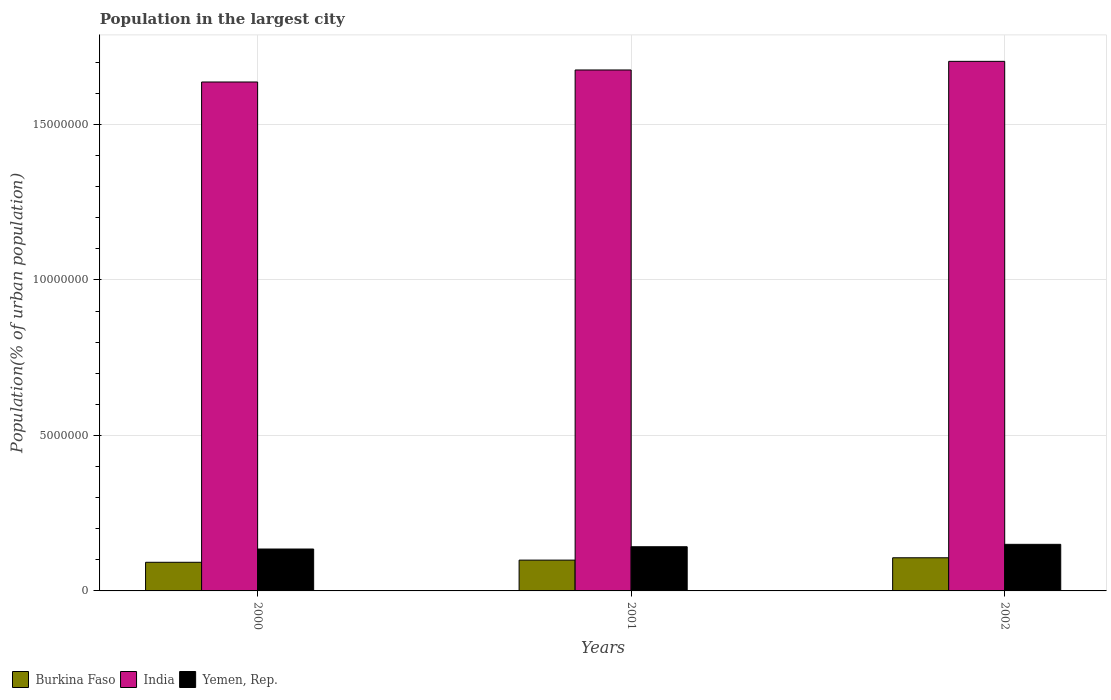How many groups of bars are there?
Provide a succinct answer. 3. Are the number of bars per tick equal to the number of legend labels?
Your response must be concise. Yes. How many bars are there on the 3rd tick from the left?
Your answer should be very brief. 3. What is the label of the 2nd group of bars from the left?
Make the answer very short. 2001. What is the population in the largest city in India in 2002?
Offer a very short reply. 1.70e+07. Across all years, what is the maximum population in the largest city in Burkina Faso?
Provide a short and direct response. 1.07e+06. Across all years, what is the minimum population in the largest city in Yemen, Rep.?
Keep it short and to the point. 1.35e+06. What is the total population in the largest city in Burkina Faso in the graph?
Offer a terse response. 2.98e+06. What is the difference between the population in the largest city in India in 2000 and that in 2002?
Keep it short and to the point. -6.64e+05. What is the difference between the population in the largest city in India in 2001 and the population in the largest city in Yemen, Rep. in 2002?
Provide a short and direct response. 1.53e+07. What is the average population in the largest city in Yemen, Rep. per year?
Give a very brief answer. 1.42e+06. In the year 2000, what is the difference between the population in the largest city in Yemen, Rep. and population in the largest city in India?
Your response must be concise. -1.50e+07. What is the ratio of the population in the largest city in Burkina Faso in 2000 to that in 2001?
Ensure brevity in your answer.  0.93. What is the difference between the highest and the second highest population in the largest city in Yemen, Rep.?
Provide a short and direct response. 7.75e+04. What is the difference between the highest and the lowest population in the largest city in India?
Make the answer very short. 6.64e+05. In how many years, is the population in the largest city in Yemen, Rep. greater than the average population in the largest city in Yemen, Rep. taken over all years?
Your response must be concise. 1. Is the sum of the population in the largest city in India in 2001 and 2002 greater than the maximum population in the largest city in Yemen, Rep. across all years?
Give a very brief answer. Yes. What does the 1st bar from the left in 2000 represents?
Make the answer very short. Burkina Faso. What does the 2nd bar from the right in 2001 represents?
Offer a very short reply. India. Is it the case that in every year, the sum of the population in the largest city in Yemen, Rep. and population in the largest city in Burkina Faso is greater than the population in the largest city in India?
Provide a succinct answer. No. How many years are there in the graph?
Offer a terse response. 3. Are the values on the major ticks of Y-axis written in scientific E-notation?
Give a very brief answer. No. Does the graph contain any zero values?
Ensure brevity in your answer.  No. Where does the legend appear in the graph?
Provide a short and direct response. Bottom left. How are the legend labels stacked?
Your answer should be very brief. Horizontal. What is the title of the graph?
Give a very brief answer. Population in the largest city. What is the label or title of the X-axis?
Give a very brief answer. Years. What is the label or title of the Y-axis?
Ensure brevity in your answer.  Population(% of urban population). What is the Population(% of urban population) in Burkina Faso in 2000?
Keep it short and to the point. 9.21e+05. What is the Population(% of urban population) of India in 2000?
Offer a very short reply. 1.64e+07. What is the Population(% of urban population) of Yemen, Rep. in 2000?
Give a very brief answer. 1.35e+06. What is the Population(% of urban population) in Burkina Faso in 2001?
Make the answer very short. 9.91e+05. What is the Population(% of urban population) of India in 2001?
Your answer should be very brief. 1.68e+07. What is the Population(% of urban population) of Yemen, Rep. in 2001?
Give a very brief answer. 1.42e+06. What is the Population(% of urban population) of Burkina Faso in 2002?
Provide a short and direct response. 1.07e+06. What is the Population(% of urban population) in India in 2002?
Offer a terse response. 1.70e+07. What is the Population(% of urban population) in Yemen, Rep. in 2002?
Provide a succinct answer. 1.50e+06. Across all years, what is the maximum Population(% of urban population) of Burkina Faso?
Your response must be concise. 1.07e+06. Across all years, what is the maximum Population(% of urban population) of India?
Your answer should be very brief. 1.70e+07. Across all years, what is the maximum Population(% of urban population) in Yemen, Rep.?
Give a very brief answer. 1.50e+06. Across all years, what is the minimum Population(% of urban population) in Burkina Faso?
Ensure brevity in your answer.  9.21e+05. Across all years, what is the minimum Population(% of urban population) of India?
Your answer should be very brief. 1.64e+07. Across all years, what is the minimum Population(% of urban population) in Yemen, Rep.?
Make the answer very short. 1.35e+06. What is the total Population(% of urban population) in Burkina Faso in the graph?
Offer a very short reply. 2.98e+06. What is the total Population(% of urban population) of India in the graph?
Offer a terse response. 5.02e+07. What is the total Population(% of urban population) in Yemen, Rep. in the graph?
Your response must be concise. 4.27e+06. What is the difference between the Population(% of urban population) in Burkina Faso in 2000 and that in 2001?
Keep it short and to the point. -6.98e+04. What is the difference between the Population(% of urban population) of India in 2000 and that in 2001?
Ensure brevity in your answer.  -3.86e+05. What is the difference between the Population(% of urban population) in Yemen, Rep. in 2000 and that in 2001?
Provide a succinct answer. -7.34e+04. What is the difference between the Population(% of urban population) in Burkina Faso in 2000 and that in 2002?
Give a very brief answer. -1.45e+05. What is the difference between the Population(% of urban population) in India in 2000 and that in 2002?
Make the answer very short. -6.64e+05. What is the difference between the Population(% of urban population) of Yemen, Rep. in 2000 and that in 2002?
Offer a terse response. -1.51e+05. What is the difference between the Population(% of urban population) of Burkina Faso in 2001 and that in 2002?
Make the answer very short. -7.52e+04. What is the difference between the Population(% of urban population) in India in 2001 and that in 2002?
Your response must be concise. -2.77e+05. What is the difference between the Population(% of urban population) of Yemen, Rep. in 2001 and that in 2002?
Your answer should be very brief. -7.75e+04. What is the difference between the Population(% of urban population) in Burkina Faso in 2000 and the Population(% of urban population) in India in 2001?
Your answer should be compact. -1.58e+07. What is the difference between the Population(% of urban population) of Burkina Faso in 2000 and the Population(% of urban population) of Yemen, Rep. in 2001?
Offer a very short reply. -5.00e+05. What is the difference between the Population(% of urban population) in India in 2000 and the Population(% of urban population) in Yemen, Rep. in 2001?
Keep it short and to the point. 1.49e+07. What is the difference between the Population(% of urban population) in Burkina Faso in 2000 and the Population(% of urban population) in India in 2002?
Make the answer very short. -1.61e+07. What is the difference between the Population(% of urban population) of Burkina Faso in 2000 and the Population(% of urban population) of Yemen, Rep. in 2002?
Offer a very short reply. -5.77e+05. What is the difference between the Population(% of urban population) of India in 2000 and the Population(% of urban population) of Yemen, Rep. in 2002?
Keep it short and to the point. 1.49e+07. What is the difference between the Population(% of urban population) of Burkina Faso in 2001 and the Population(% of urban population) of India in 2002?
Provide a succinct answer. -1.60e+07. What is the difference between the Population(% of urban population) in Burkina Faso in 2001 and the Population(% of urban population) in Yemen, Rep. in 2002?
Make the answer very short. -5.08e+05. What is the difference between the Population(% of urban population) of India in 2001 and the Population(% of urban population) of Yemen, Rep. in 2002?
Keep it short and to the point. 1.53e+07. What is the average Population(% of urban population) in Burkina Faso per year?
Give a very brief answer. 9.92e+05. What is the average Population(% of urban population) of India per year?
Provide a short and direct response. 1.67e+07. What is the average Population(% of urban population) in Yemen, Rep. per year?
Provide a succinct answer. 1.42e+06. In the year 2000, what is the difference between the Population(% of urban population) of Burkina Faso and Population(% of urban population) of India?
Provide a succinct answer. -1.54e+07. In the year 2000, what is the difference between the Population(% of urban population) in Burkina Faso and Population(% of urban population) in Yemen, Rep.?
Give a very brief answer. -4.26e+05. In the year 2000, what is the difference between the Population(% of urban population) of India and Population(% of urban population) of Yemen, Rep.?
Your answer should be compact. 1.50e+07. In the year 2001, what is the difference between the Population(% of urban population) in Burkina Faso and Population(% of urban population) in India?
Your answer should be very brief. -1.58e+07. In the year 2001, what is the difference between the Population(% of urban population) of Burkina Faso and Population(% of urban population) of Yemen, Rep.?
Your answer should be very brief. -4.30e+05. In the year 2001, what is the difference between the Population(% of urban population) in India and Population(% of urban population) in Yemen, Rep.?
Your response must be concise. 1.53e+07. In the year 2002, what is the difference between the Population(% of urban population) in Burkina Faso and Population(% of urban population) in India?
Keep it short and to the point. -1.60e+07. In the year 2002, what is the difference between the Population(% of urban population) of Burkina Faso and Population(% of urban population) of Yemen, Rep.?
Provide a succinct answer. -4.32e+05. In the year 2002, what is the difference between the Population(% of urban population) of India and Population(% of urban population) of Yemen, Rep.?
Provide a succinct answer. 1.55e+07. What is the ratio of the Population(% of urban population) of Burkina Faso in 2000 to that in 2001?
Keep it short and to the point. 0.93. What is the ratio of the Population(% of urban population) in India in 2000 to that in 2001?
Ensure brevity in your answer.  0.98. What is the ratio of the Population(% of urban population) of Yemen, Rep. in 2000 to that in 2001?
Provide a short and direct response. 0.95. What is the ratio of the Population(% of urban population) in Burkina Faso in 2000 to that in 2002?
Give a very brief answer. 0.86. What is the ratio of the Population(% of urban population) in India in 2000 to that in 2002?
Keep it short and to the point. 0.96. What is the ratio of the Population(% of urban population) of Yemen, Rep. in 2000 to that in 2002?
Give a very brief answer. 0.9. What is the ratio of the Population(% of urban population) in Burkina Faso in 2001 to that in 2002?
Offer a very short reply. 0.93. What is the ratio of the Population(% of urban population) of India in 2001 to that in 2002?
Ensure brevity in your answer.  0.98. What is the ratio of the Population(% of urban population) in Yemen, Rep. in 2001 to that in 2002?
Your answer should be compact. 0.95. What is the difference between the highest and the second highest Population(% of urban population) of Burkina Faso?
Your answer should be compact. 7.52e+04. What is the difference between the highest and the second highest Population(% of urban population) of India?
Keep it short and to the point. 2.77e+05. What is the difference between the highest and the second highest Population(% of urban population) in Yemen, Rep.?
Your answer should be very brief. 7.75e+04. What is the difference between the highest and the lowest Population(% of urban population) in Burkina Faso?
Your response must be concise. 1.45e+05. What is the difference between the highest and the lowest Population(% of urban population) of India?
Provide a short and direct response. 6.64e+05. What is the difference between the highest and the lowest Population(% of urban population) in Yemen, Rep.?
Make the answer very short. 1.51e+05. 